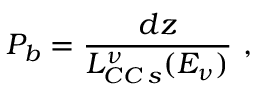Convert formula to latex. <formula><loc_0><loc_0><loc_500><loc_500>P _ { b } = \frac { d z } { L _ { C C \, s } ^ { \nu } ( E _ { \nu } ) } \ ,</formula> 